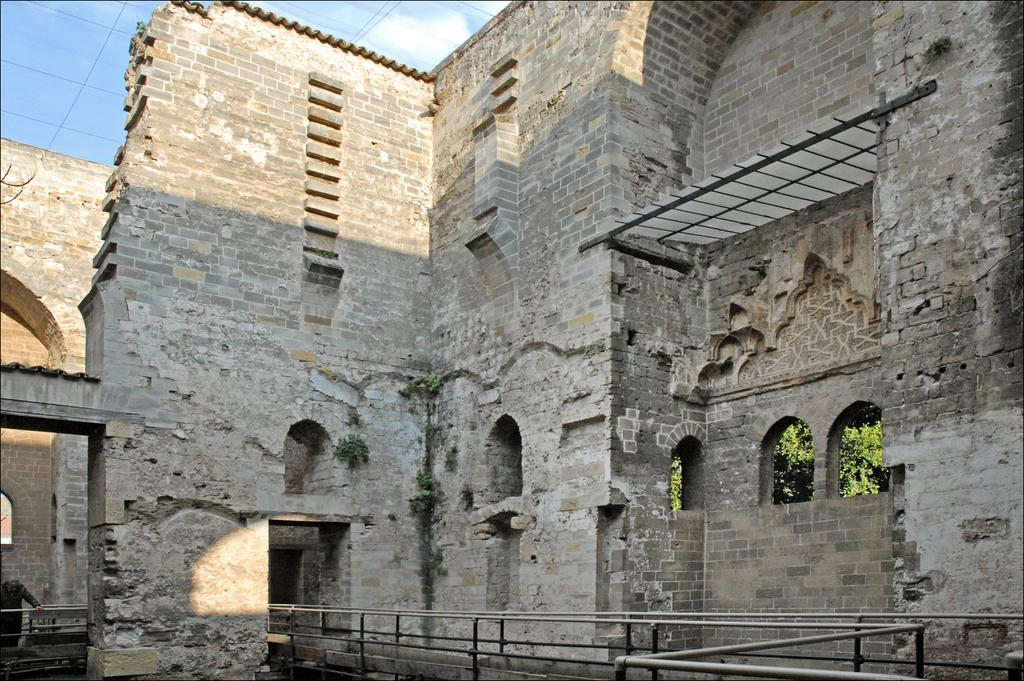What type of structure is in the picture? There is an old granite fort in the picture. What design feature can be seen on the windows of the fort? The fort has arch design windows. What type of railing is present in the front of the fort? There is a pipe railing in the front of the fort. What color bead is hanging from the pipe railing in the image? There is no bead present in the image, so it cannot be determined what color it might be. 